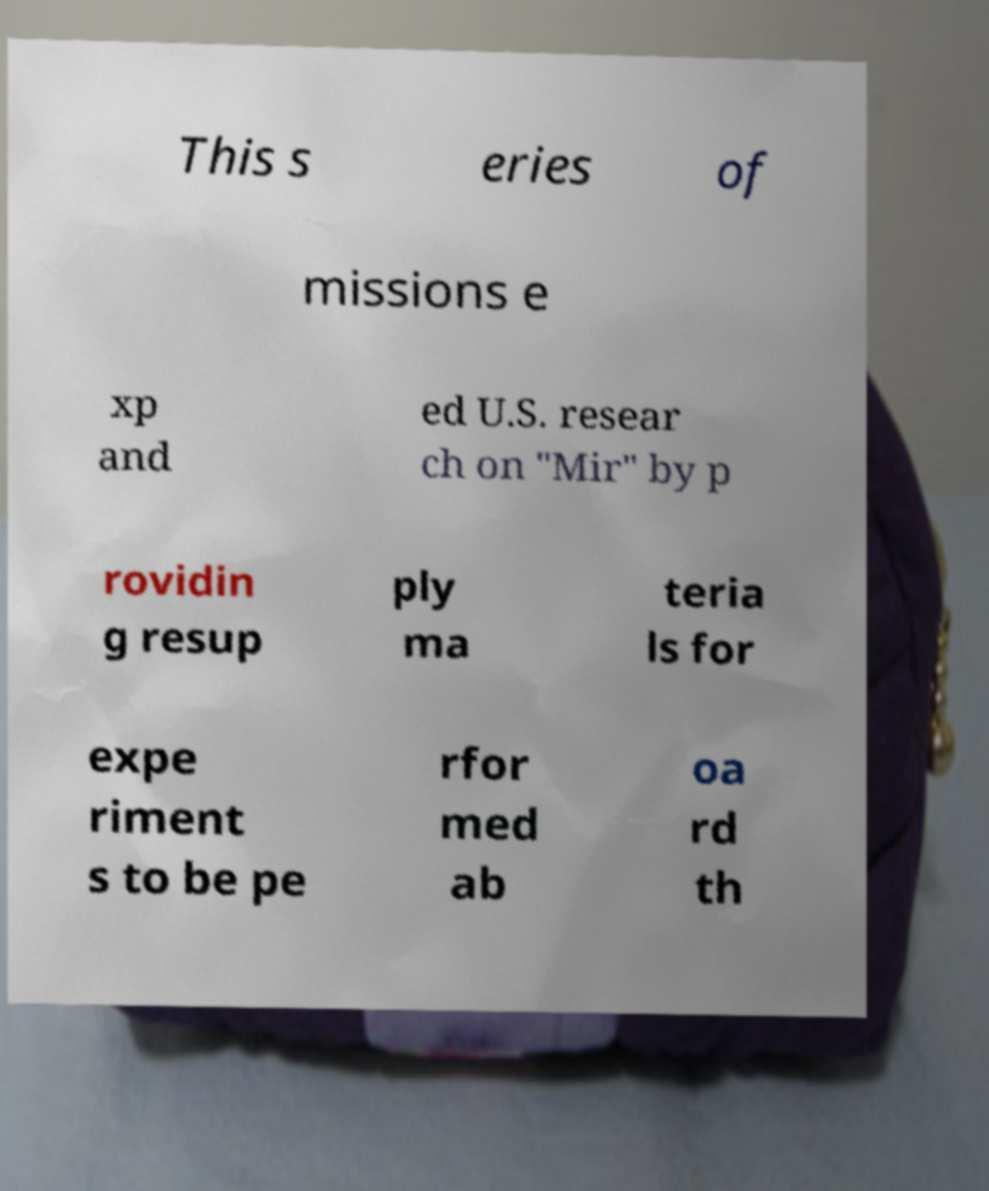There's text embedded in this image that I need extracted. Can you transcribe it verbatim? This s eries of missions e xp and ed U.S. resear ch on "Mir" by p rovidin g resup ply ma teria ls for expe riment s to be pe rfor med ab oa rd th 